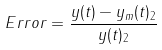<formula> <loc_0><loc_0><loc_500><loc_500>{ E r r o r } = \frac { \| { y } ( t ) - { y } _ { m } ( t ) \| _ { 2 } } { \| { y } ( t ) \| _ { 2 } }</formula> 